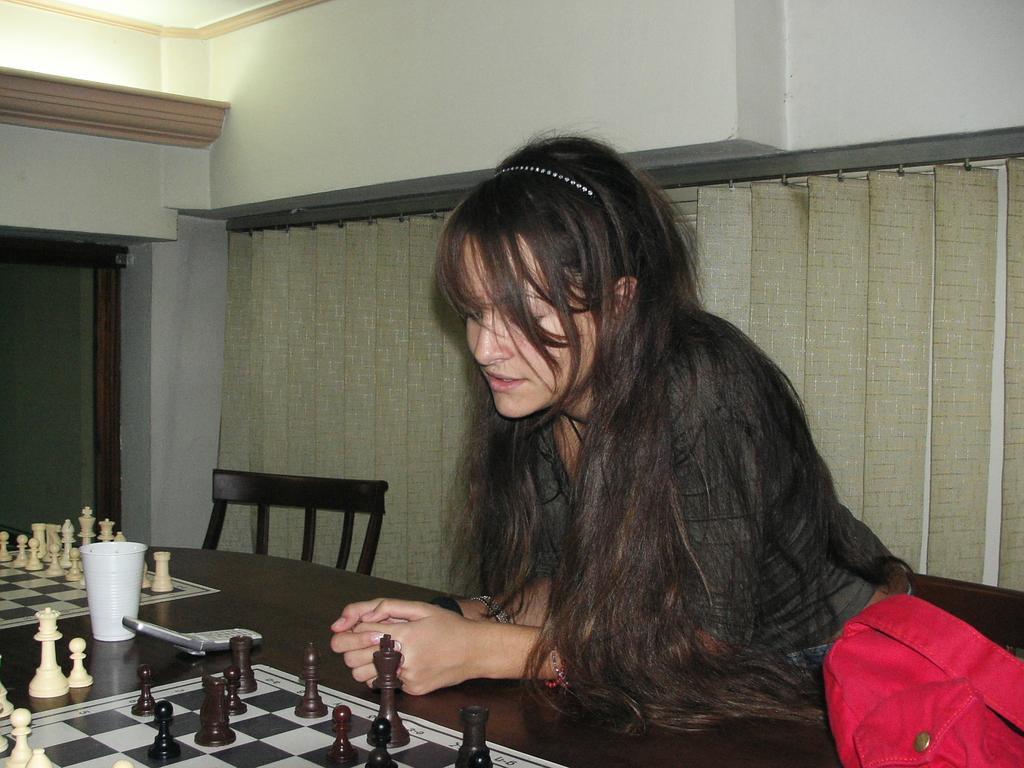Describe this image in one or two sentences. This picture shows a woman seated on the chair and playing chess And we see blinds back of her 